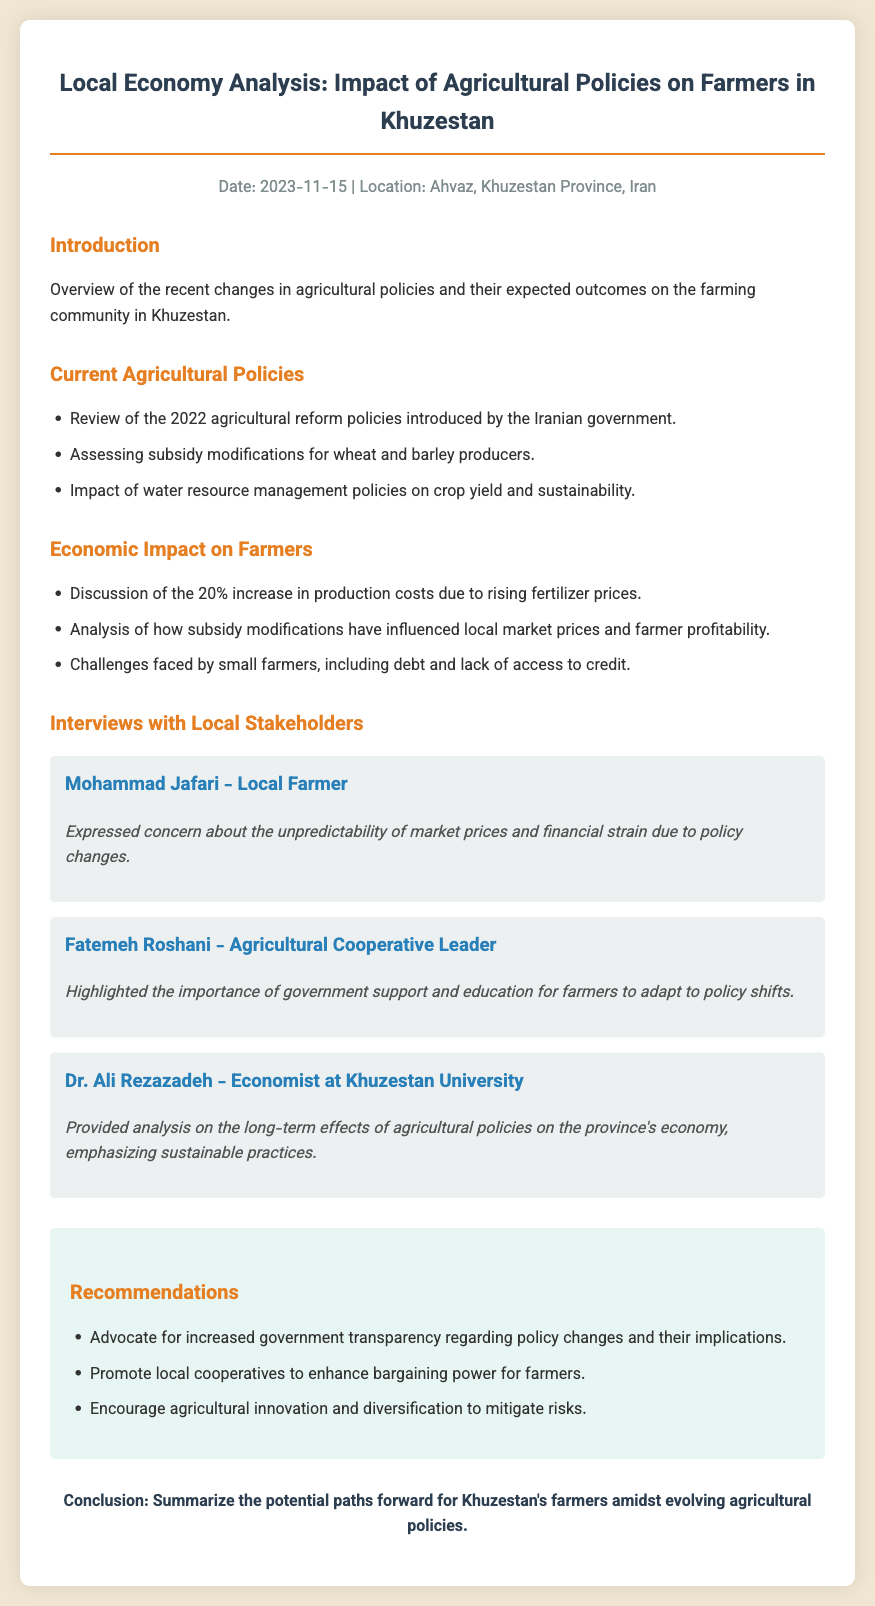What is the date of the report? The date of the report is mentioned in the meta section at the top of the document.
Answer: 2023-11-15 Who is the local farmer interviewed? The document highlights interviews with local stakeholders, one of whom is identified as a farmer.
Answer: Mohammad Jafari What percentage increase in production costs is discussed? The document states the specific percentage increase in production costs due to rising fertilizer prices.
Answer: 20% What type of policies were reviewed in the document? The document mentions specific policies related to agriculture that were introduced or modified.
Answer: Agricultural reform policies Who emphasized the importance of government support? The document cites opinions from various stakeholders, identifying who stressed the need for government assistance.
Answer: Fatemeh Roshani What economic institution does Dr. Ali Rezazadeh represent? The document specifies the professional role of Dr. Rezazadeh in the context of the interviews.
Answer: Khuzestan University What is one of the recommendations mentioned? The recommendations section includes specific advice aimed at improving the situation for farmers.
Answer: Advocate for increased government transparency What color theme is used for the main title in the document? The color used for the main title is described in the styling of the document.
Answer: #2c3e50 